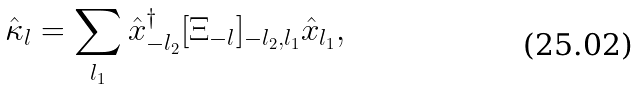<formula> <loc_0><loc_0><loc_500><loc_500>\hat { \kappa } _ { l } = \sum _ { l _ { 1 } } \hat { x } _ { - l _ { 2 } } ^ { \dagger } [ \Xi _ { - l } ] _ { - l _ { 2 } , l _ { 1 } } \hat { x } _ { l _ { 1 } } ,</formula> 